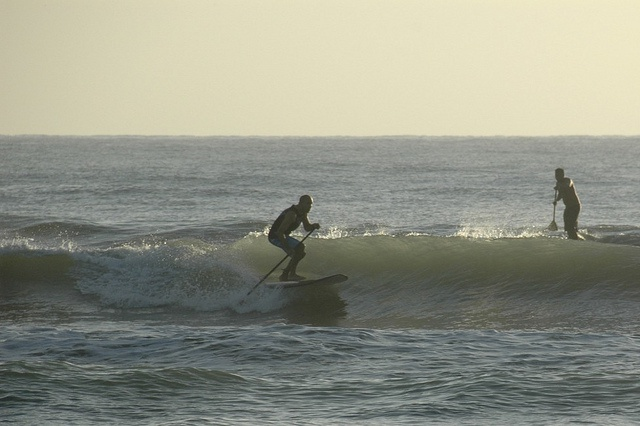Describe the objects in this image and their specific colors. I can see people in tan, black, gray, and darkgray tones, people in tan, black, darkgray, and gray tones, and surfboard in tan, black, and gray tones in this image. 